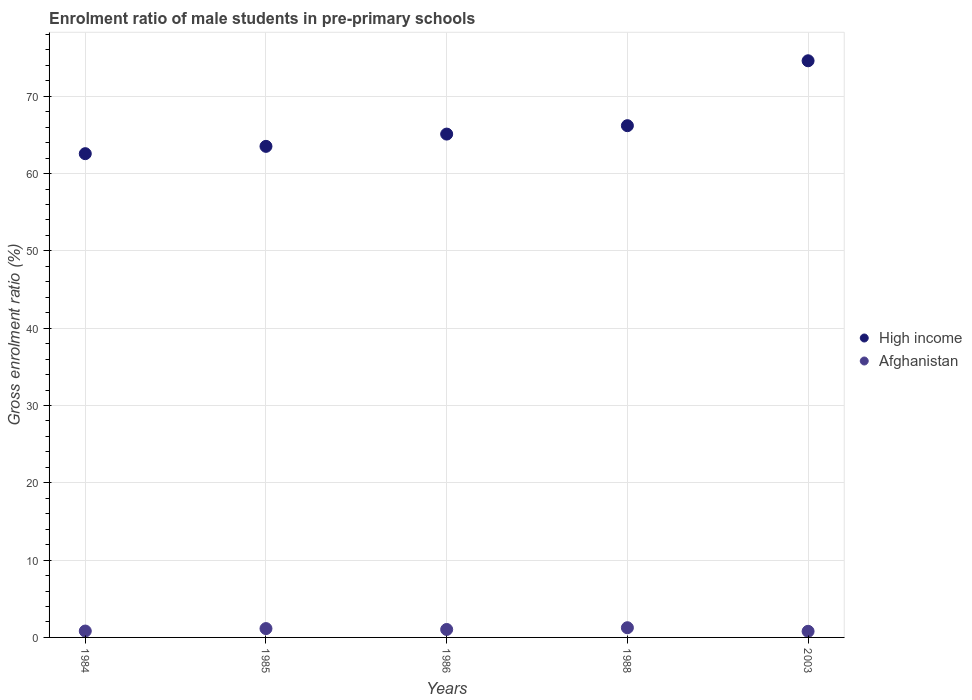What is the enrolment ratio of male students in pre-primary schools in High income in 1984?
Offer a very short reply. 62.57. Across all years, what is the maximum enrolment ratio of male students in pre-primary schools in Afghanistan?
Your response must be concise. 1.25. Across all years, what is the minimum enrolment ratio of male students in pre-primary schools in Afghanistan?
Make the answer very short. 0.79. In which year was the enrolment ratio of male students in pre-primary schools in High income maximum?
Your answer should be very brief. 2003. In which year was the enrolment ratio of male students in pre-primary schools in High income minimum?
Provide a succinct answer. 1984. What is the total enrolment ratio of male students in pre-primary schools in High income in the graph?
Offer a terse response. 331.96. What is the difference between the enrolment ratio of male students in pre-primary schools in Afghanistan in 1985 and that in 1986?
Your response must be concise. 0.12. What is the difference between the enrolment ratio of male students in pre-primary schools in Afghanistan in 1988 and the enrolment ratio of male students in pre-primary schools in High income in 1986?
Offer a terse response. -63.85. What is the average enrolment ratio of male students in pre-primary schools in Afghanistan per year?
Ensure brevity in your answer.  1.01. In the year 1985, what is the difference between the enrolment ratio of male students in pre-primary schools in High income and enrolment ratio of male students in pre-primary schools in Afghanistan?
Make the answer very short. 62.37. In how many years, is the enrolment ratio of male students in pre-primary schools in High income greater than 24 %?
Your answer should be compact. 5. What is the ratio of the enrolment ratio of male students in pre-primary schools in Afghanistan in 1984 to that in 1986?
Provide a short and direct response. 0.8. Is the enrolment ratio of male students in pre-primary schools in Afghanistan in 1985 less than that in 2003?
Keep it short and to the point. No. What is the difference between the highest and the second highest enrolment ratio of male students in pre-primary schools in High income?
Offer a very short reply. 8.39. What is the difference between the highest and the lowest enrolment ratio of male students in pre-primary schools in High income?
Your response must be concise. 12.02. In how many years, is the enrolment ratio of male students in pre-primary schools in Afghanistan greater than the average enrolment ratio of male students in pre-primary schools in Afghanistan taken over all years?
Your response must be concise. 3. Is the sum of the enrolment ratio of male students in pre-primary schools in High income in 1984 and 1985 greater than the maximum enrolment ratio of male students in pre-primary schools in Afghanistan across all years?
Offer a very short reply. Yes. Is the enrolment ratio of male students in pre-primary schools in Afghanistan strictly less than the enrolment ratio of male students in pre-primary schools in High income over the years?
Offer a very short reply. Yes. How many years are there in the graph?
Offer a very short reply. 5. What is the difference between two consecutive major ticks on the Y-axis?
Offer a terse response. 10. Are the values on the major ticks of Y-axis written in scientific E-notation?
Give a very brief answer. No. What is the title of the graph?
Your response must be concise. Enrolment ratio of male students in pre-primary schools. What is the label or title of the X-axis?
Your answer should be very brief. Years. What is the label or title of the Y-axis?
Offer a terse response. Gross enrolment ratio (%). What is the Gross enrolment ratio (%) of High income in 1984?
Provide a short and direct response. 62.57. What is the Gross enrolment ratio (%) of Afghanistan in 1984?
Offer a very short reply. 0.83. What is the Gross enrolment ratio (%) of High income in 1985?
Provide a succinct answer. 63.52. What is the Gross enrolment ratio (%) in Afghanistan in 1985?
Provide a short and direct response. 1.14. What is the Gross enrolment ratio (%) of High income in 1986?
Your response must be concise. 65.1. What is the Gross enrolment ratio (%) of Afghanistan in 1986?
Ensure brevity in your answer.  1.03. What is the Gross enrolment ratio (%) of High income in 1988?
Provide a short and direct response. 66.19. What is the Gross enrolment ratio (%) of Afghanistan in 1988?
Ensure brevity in your answer.  1.25. What is the Gross enrolment ratio (%) in High income in 2003?
Ensure brevity in your answer.  74.58. What is the Gross enrolment ratio (%) of Afghanistan in 2003?
Give a very brief answer. 0.79. Across all years, what is the maximum Gross enrolment ratio (%) in High income?
Your response must be concise. 74.58. Across all years, what is the maximum Gross enrolment ratio (%) in Afghanistan?
Make the answer very short. 1.25. Across all years, what is the minimum Gross enrolment ratio (%) of High income?
Provide a succinct answer. 62.57. Across all years, what is the minimum Gross enrolment ratio (%) of Afghanistan?
Your response must be concise. 0.79. What is the total Gross enrolment ratio (%) in High income in the graph?
Provide a succinct answer. 331.96. What is the total Gross enrolment ratio (%) of Afghanistan in the graph?
Provide a succinct answer. 5.04. What is the difference between the Gross enrolment ratio (%) of High income in 1984 and that in 1985?
Ensure brevity in your answer.  -0.95. What is the difference between the Gross enrolment ratio (%) in Afghanistan in 1984 and that in 1985?
Give a very brief answer. -0.32. What is the difference between the Gross enrolment ratio (%) in High income in 1984 and that in 1986?
Your answer should be very brief. -2.53. What is the difference between the Gross enrolment ratio (%) of Afghanistan in 1984 and that in 1986?
Provide a short and direct response. -0.2. What is the difference between the Gross enrolment ratio (%) of High income in 1984 and that in 1988?
Your answer should be very brief. -3.62. What is the difference between the Gross enrolment ratio (%) of Afghanistan in 1984 and that in 1988?
Provide a short and direct response. -0.43. What is the difference between the Gross enrolment ratio (%) in High income in 1984 and that in 2003?
Give a very brief answer. -12.02. What is the difference between the Gross enrolment ratio (%) of Afghanistan in 1984 and that in 2003?
Offer a terse response. 0.04. What is the difference between the Gross enrolment ratio (%) of High income in 1985 and that in 1986?
Give a very brief answer. -1.59. What is the difference between the Gross enrolment ratio (%) of Afghanistan in 1985 and that in 1986?
Make the answer very short. 0.12. What is the difference between the Gross enrolment ratio (%) in High income in 1985 and that in 1988?
Keep it short and to the point. -2.67. What is the difference between the Gross enrolment ratio (%) in Afghanistan in 1985 and that in 1988?
Keep it short and to the point. -0.11. What is the difference between the Gross enrolment ratio (%) of High income in 1985 and that in 2003?
Your response must be concise. -11.07. What is the difference between the Gross enrolment ratio (%) of Afghanistan in 1985 and that in 2003?
Offer a terse response. 0.35. What is the difference between the Gross enrolment ratio (%) in High income in 1986 and that in 1988?
Your answer should be compact. -1.09. What is the difference between the Gross enrolment ratio (%) of Afghanistan in 1986 and that in 1988?
Offer a very short reply. -0.23. What is the difference between the Gross enrolment ratio (%) in High income in 1986 and that in 2003?
Keep it short and to the point. -9.48. What is the difference between the Gross enrolment ratio (%) in Afghanistan in 1986 and that in 2003?
Provide a short and direct response. 0.24. What is the difference between the Gross enrolment ratio (%) of High income in 1988 and that in 2003?
Provide a succinct answer. -8.39. What is the difference between the Gross enrolment ratio (%) in Afghanistan in 1988 and that in 2003?
Provide a short and direct response. 0.46. What is the difference between the Gross enrolment ratio (%) of High income in 1984 and the Gross enrolment ratio (%) of Afghanistan in 1985?
Keep it short and to the point. 61.42. What is the difference between the Gross enrolment ratio (%) in High income in 1984 and the Gross enrolment ratio (%) in Afghanistan in 1986?
Ensure brevity in your answer.  61.54. What is the difference between the Gross enrolment ratio (%) of High income in 1984 and the Gross enrolment ratio (%) of Afghanistan in 1988?
Provide a succinct answer. 61.31. What is the difference between the Gross enrolment ratio (%) in High income in 1984 and the Gross enrolment ratio (%) in Afghanistan in 2003?
Provide a succinct answer. 61.78. What is the difference between the Gross enrolment ratio (%) in High income in 1985 and the Gross enrolment ratio (%) in Afghanistan in 1986?
Offer a terse response. 62.49. What is the difference between the Gross enrolment ratio (%) in High income in 1985 and the Gross enrolment ratio (%) in Afghanistan in 1988?
Keep it short and to the point. 62.26. What is the difference between the Gross enrolment ratio (%) of High income in 1985 and the Gross enrolment ratio (%) of Afghanistan in 2003?
Provide a succinct answer. 62.73. What is the difference between the Gross enrolment ratio (%) in High income in 1986 and the Gross enrolment ratio (%) in Afghanistan in 1988?
Provide a short and direct response. 63.85. What is the difference between the Gross enrolment ratio (%) of High income in 1986 and the Gross enrolment ratio (%) of Afghanistan in 2003?
Your response must be concise. 64.31. What is the difference between the Gross enrolment ratio (%) of High income in 1988 and the Gross enrolment ratio (%) of Afghanistan in 2003?
Offer a very short reply. 65.4. What is the average Gross enrolment ratio (%) of High income per year?
Provide a short and direct response. 66.39. What is the average Gross enrolment ratio (%) in Afghanistan per year?
Provide a short and direct response. 1.01. In the year 1984, what is the difference between the Gross enrolment ratio (%) in High income and Gross enrolment ratio (%) in Afghanistan?
Your answer should be very brief. 61.74. In the year 1985, what is the difference between the Gross enrolment ratio (%) in High income and Gross enrolment ratio (%) in Afghanistan?
Offer a very short reply. 62.37. In the year 1986, what is the difference between the Gross enrolment ratio (%) of High income and Gross enrolment ratio (%) of Afghanistan?
Give a very brief answer. 64.07. In the year 1988, what is the difference between the Gross enrolment ratio (%) in High income and Gross enrolment ratio (%) in Afghanistan?
Provide a short and direct response. 64.94. In the year 2003, what is the difference between the Gross enrolment ratio (%) of High income and Gross enrolment ratio (%) of Afghanistan?
Give a very brief answer. 73.79. What is the ratio of the Gross enrolment ratio (%) in High income in 1984 to that in 1985?
Provide a succinct answer. 0.99. What is the ratio of the Gross enrolment ratio (%) of Afghanistan in 1984 to that in 1985?
Your response must be concise. 0.72. What is the ratio of the Gross enrolment ratio (%) in High income in 1984 to that in 1986?
Give a very brief answer. 0.96. What is the ratio of the Gross enrolment ratio (%) of Afghanistan in 1984 to that in 1986?
Provide a succinct answer. 0.8. What is the ratio of the Gross enrolment ratio (%) in High income in 1984 to that in 1988?
Make the answer very short. 0.95. What is the ratio of the Gross enrolment ratio (%) in Afghanistan in 1984 to that in 1988?
Provide a short and direct response. 0.66. What is the ratio of the Gross enrolment ratio (%) of High income in 1984 to that in 2003?
Your answer should be compact. 0.84. What is the ratio of the Gross enrolment ratio (%) of Afghanistan in 1984 to that in 2003?
Make the answer very short. 1.05. What is the ratio of the Gross enrolment ratio (%) of High income in 1985 to that in 1986?
Offer a very short reply. 0.98. What is the ratio of the Gross enrolment ratio (%) of Afghanistan in 1985 to that in 1986?
Keep it short and to the point. 1.11. What is the ratio of the Gross enrolment ratio (%) of High income in 1985 to that in 1988?
Your response must be concise. 0.96. What is the ratio of the Gross enrolment ratio (%) of Afghanistan in 1985 to that in 1988?
Offer a very short reply. 0.91. What is the ratio of the Gross enrolment ratio (%) in High income in 1985 to that in 2003?
Make the answer very short. 0.85. What is the ratio of the Gross enrolment ratio (%) of Afghanistan in 1985 to that in 2003?
Offer a very short reply. 1.45. What is the ratio of the Gross enrolment ratio (%) of High income in 1986 to that in 1988?
Provide a short and direct response. 0.98. What is the ratio of the Gross enrolment ratio (%) in Afghanistan in 1986 to that in 1988?
Your answer should be compact. 0.82. What is the ratio of the Gross enrolment ratio (%) in High income in 1986 to that in 2003?
Provide a succinct answer. 0.87. What is the ratio of the Gross enrolment ratio (%) of Afghanistan in 1986 to that in 2003?
Make the answer very short. 1.3. What is the ratio of the Gross enrolment ratio (%) in High income in 1988 to that in 2003?
Ensure brevity in your answer.  0.89. What is the ratio of the Gross enrolment ratio (%) in Afghanistan in 1988 to that in 2003?
Your response must be concise. 1.59. What is the difference between the highest and the second highest Gross enrolment ratio (%) in High income?
Give a very brief answer. 8.39. What is the difference between the highest and the second highest Gross enrolment ratio (%) in Afghanistan?
Provide a short and direct response. 0.11. What is the difference between the highest and the lowest Gross enrolment ratio (%) of High income?
Provide a succinct answer. 12.02. What is the difference between the highest and the lowest Gross enrolment ratio (%) in Afghanistan?
Offer a very short reply. 0.46. 